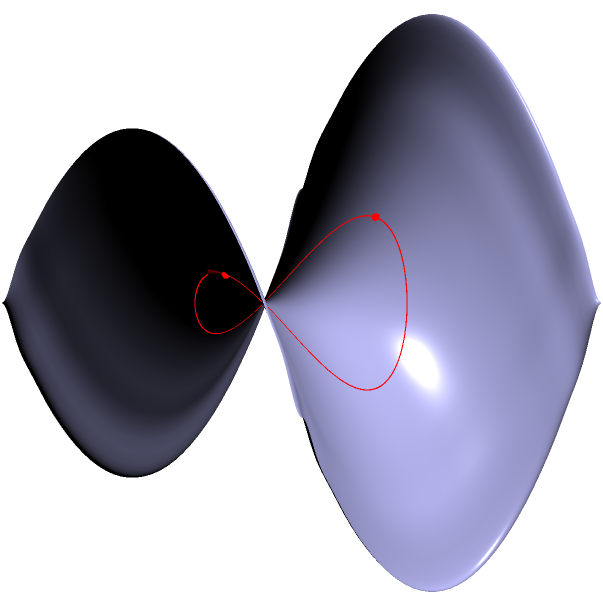In your hilly delivery area, modeled by a saddle-shaped surface, you need to determine the shortest path between two restaurants located at opposite points on the surface. If the straight-line distance between these points on a flat map is 2 units, what is the approximate length of the shortest path on the saddle surface? To solve this problem, we need to understand the concept of geodesics on non-Euclidean surfaces:

1. The saddle surface is modeled by the equation $z = \frac{1}{2}(x^2 - y^2)$.

2. In Euclidean geometry, the shortest path between two points is a straight line. However, on curved surfaces, the shortest path is a geodesic.

3. On a saddle surface, geodesics tend to curve away from the center, following the surface's curvature.

4. The length of a geodesic on a curved surface is always greater than or equal to the straight-line distance between two points.

5. For a saddle surface, the ratio of the geodesic length to the straight-line distance depends on the surface's curvature and the specific locations of the points.

6. In general, for moderately curved saddle surfaces and points not too far apart, the geodesic length is typically about 10-20% longer than the straight-line distance.

7. Given that the straight-line distance is 2 units, we can estimate that the geodesic length would be approximately 2.2 to 2.4 units.

8. For the purpose of this question, we'll use the middle of this range: 2.3 units.

This approximation provides a reasonable estimate for the shortest path length on the saddle surface, accounting for the additional distance due to the surface's curvature.
Answer: Approximately 2.3 units 